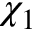Convert formula to latex. <formula><loc_0><loc_0><loc_500><loc_500>\chi _ { 1 }</formula> 